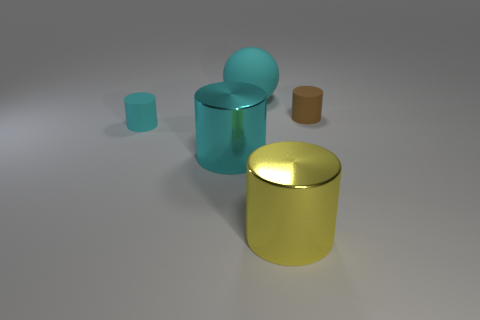Add 5 cyan rubber things. How many objects exist? 10 Subtract all green cylinders. Subtract all cyan cubes. How many cylinders are left? 4 Subtract all balls. How many objects are left? 4 Add 5 big cyan spheres. How many big cyan spheres exist? 6 Subtract 0 brown cubes. How many objects are left? 5 Subtract all tiny cyan matte cylinders. Subtract all large rubber spheres. How many objects are left? 3 Add 2 yellow metallic cylinders. How many yellow metallic cylinders are left? 3 